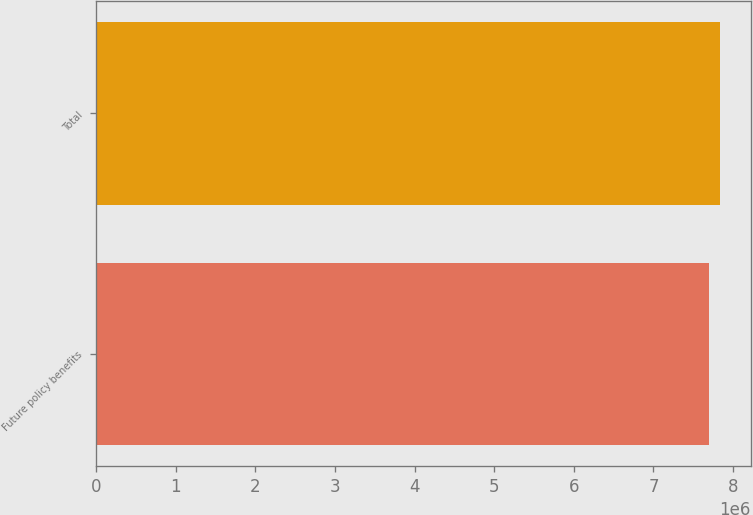<chart> <loc_0><loc_0><loc_500><loc_500><bar_chart><fcel>Future policy benefits<fcel>Total<nl><fcel>7.69711e+06<fcel>7.83281e+06<nl></chart> 